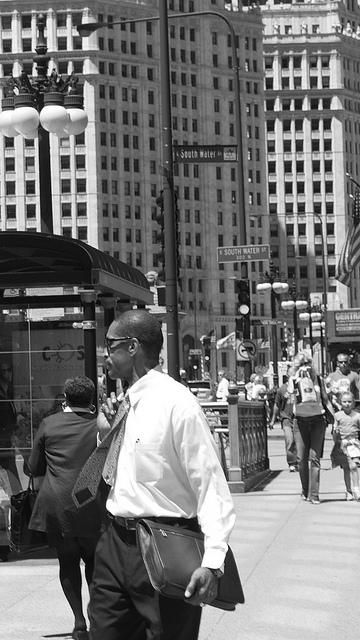Is this man going to work?
Short answer required. Yes. What time of day is it?
Concise answer only. Afternoon. What is on the man's face?
Quick response, please. Glasses. 